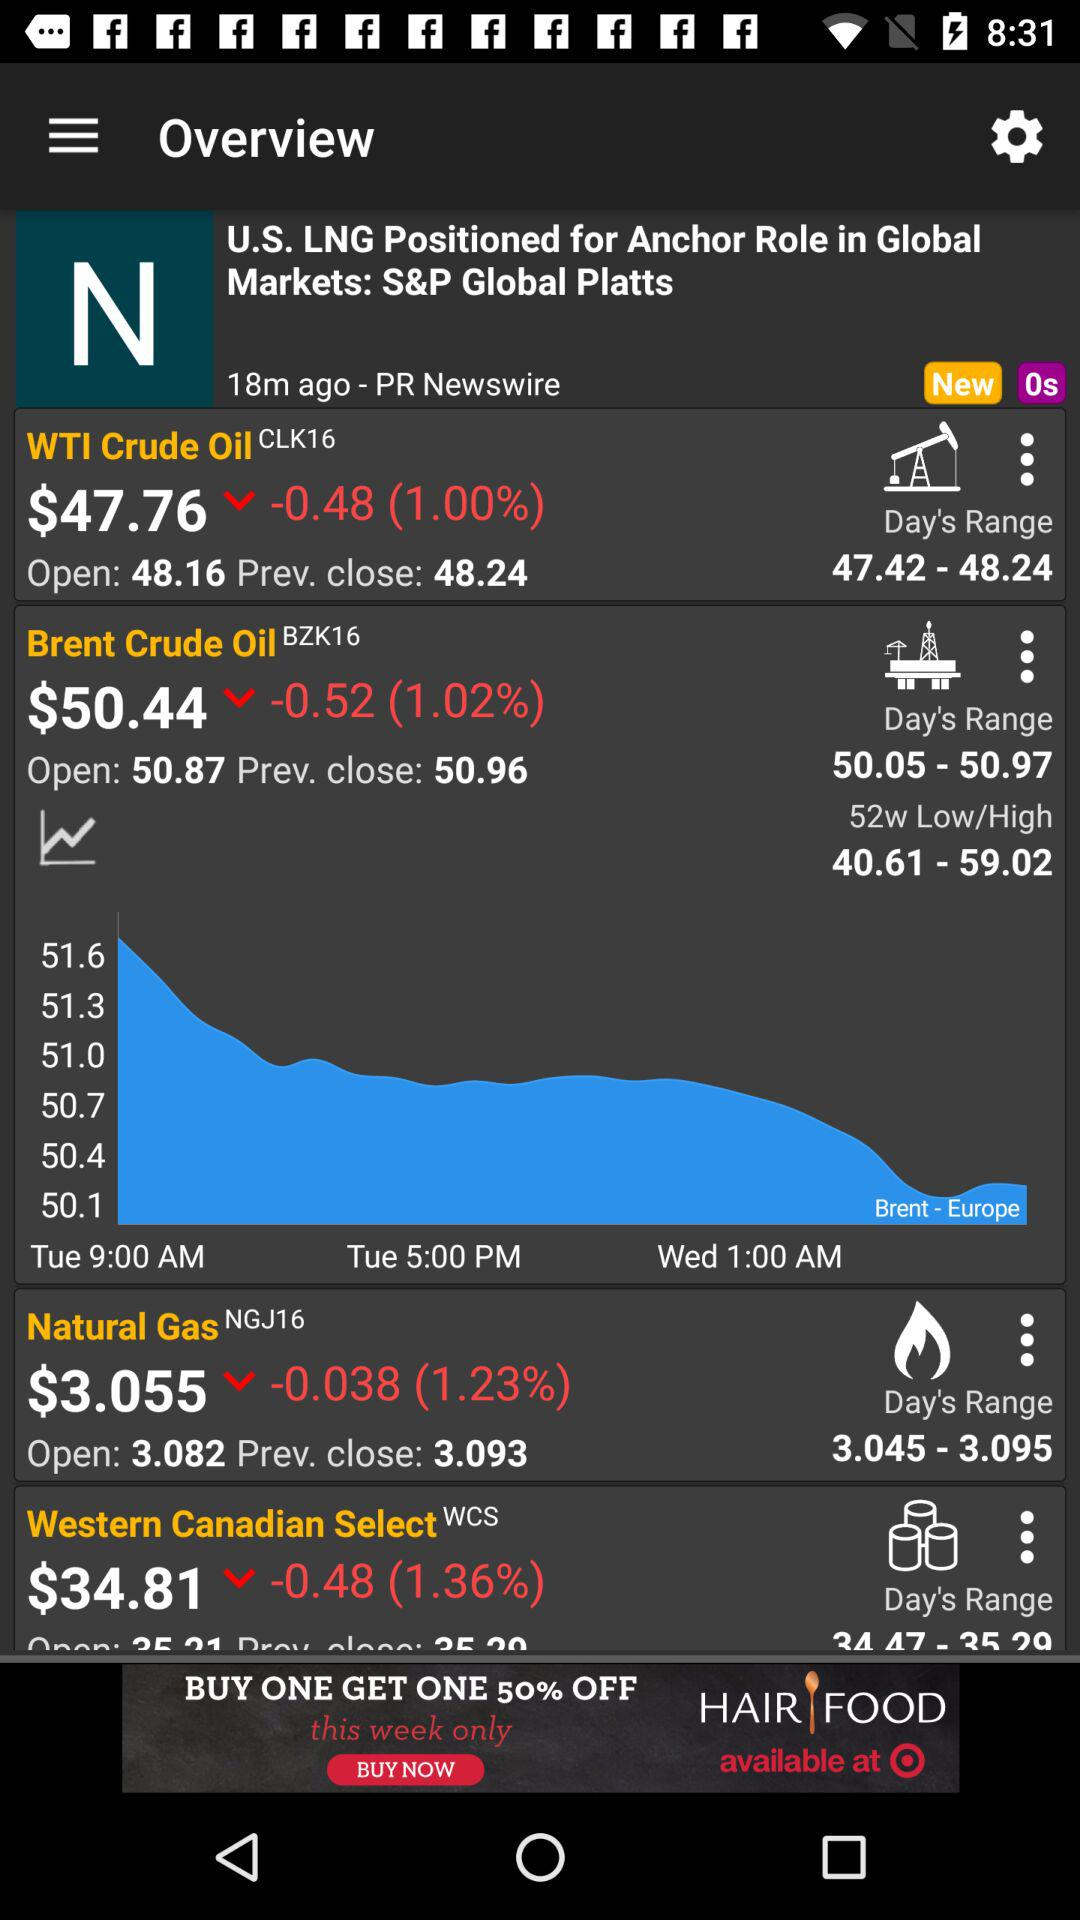What is the price of the "Natural Gas" derivative? The price is $3.055. 